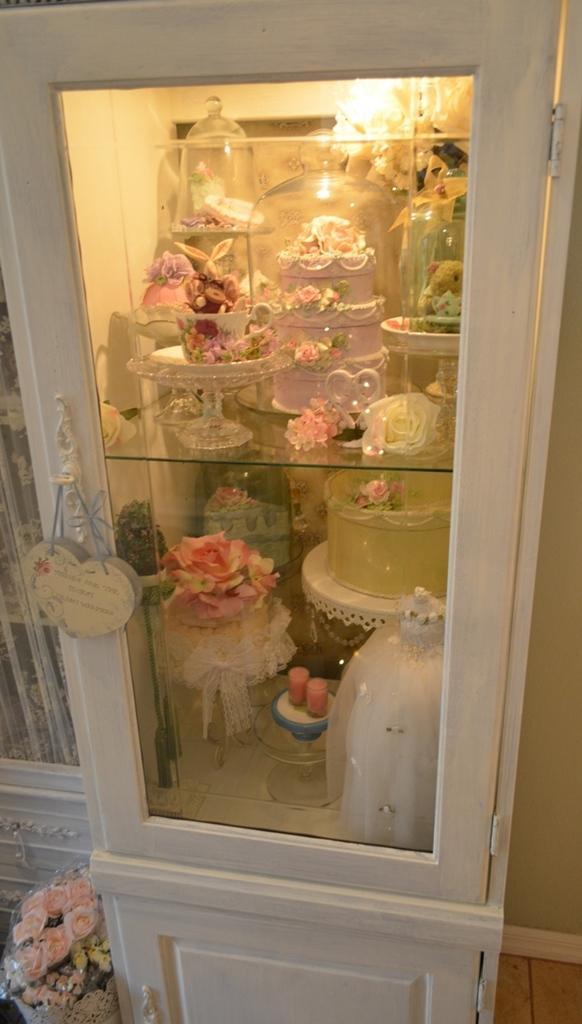In one or two sentences, can you explain what this image depicts? In the center of the image there is a shelf. In which there are many objects. 